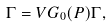Convert formula to latex. <formula><loc_0><loc_0><loc_500><loc_500>\Gamma = V G _ { 0 } ( P ) \Gamma ,</formula> 